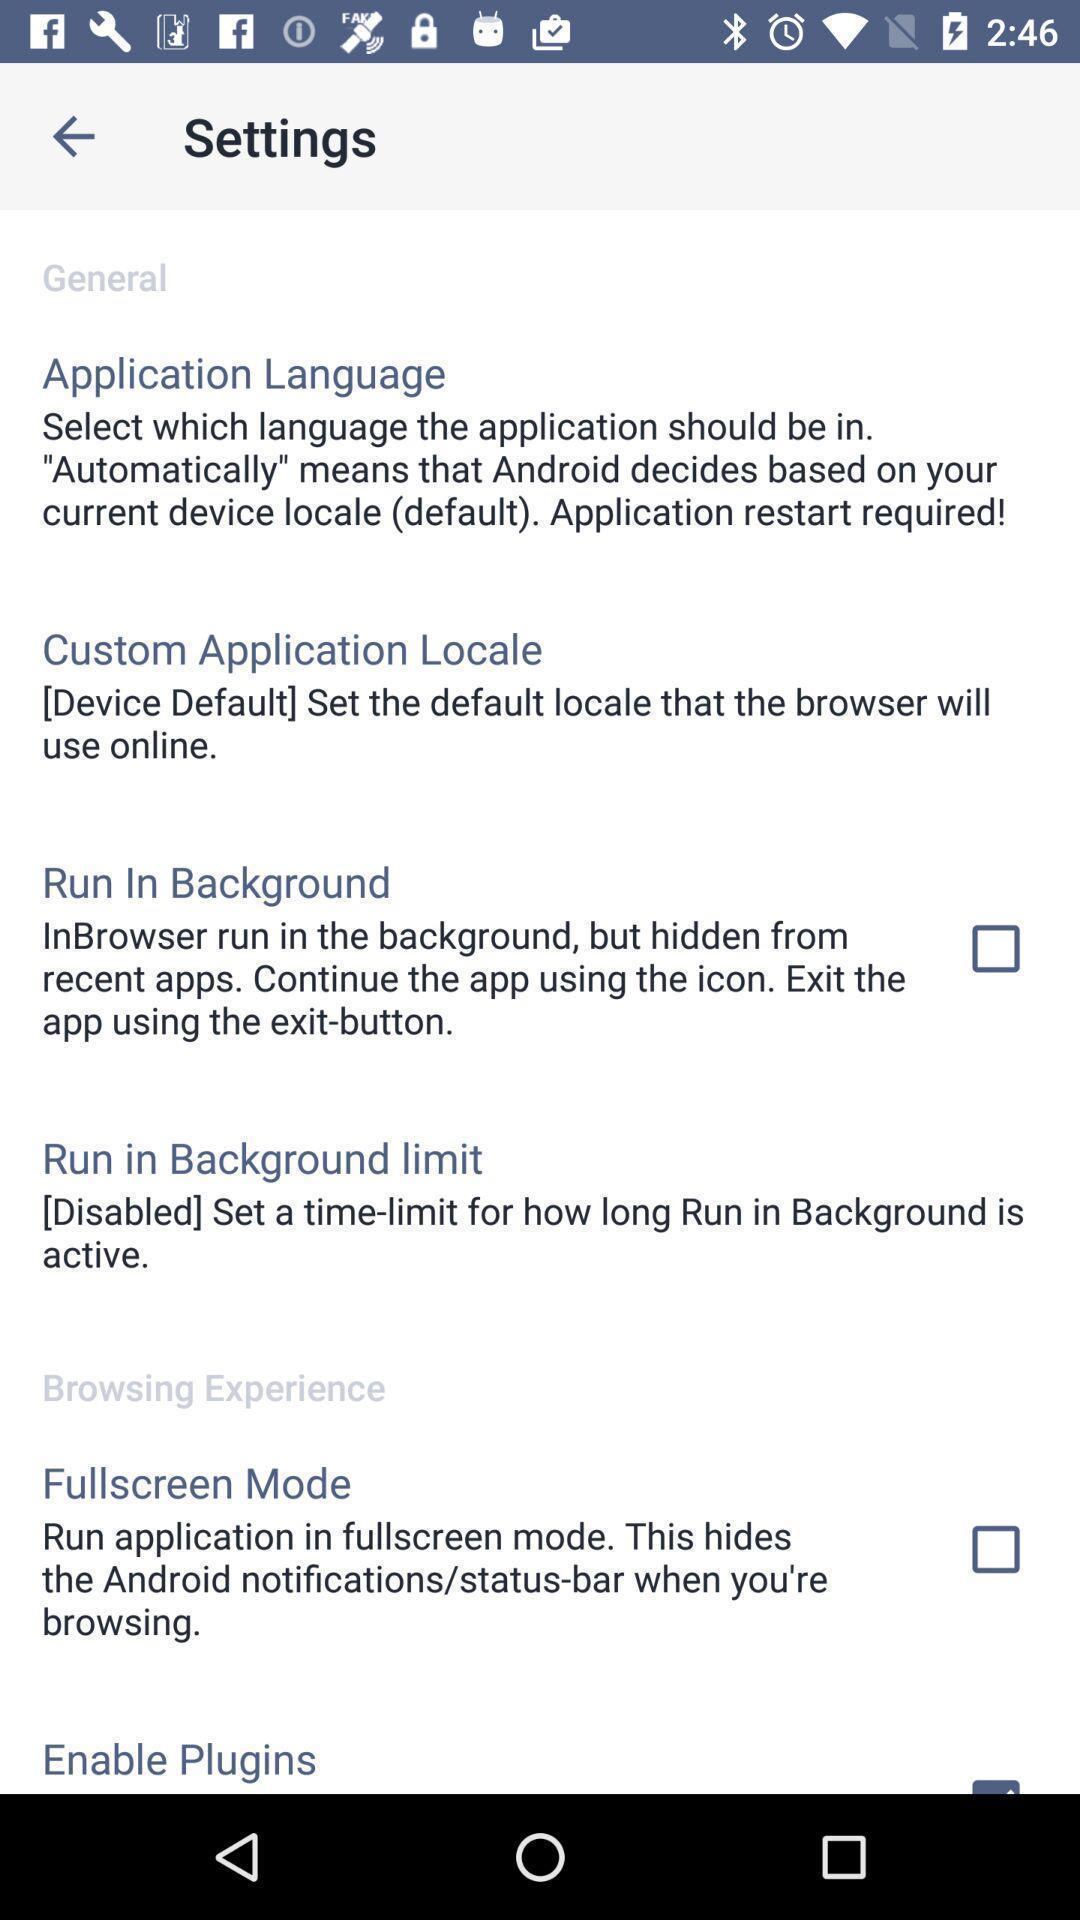Summarize the information in this screenshot. Settings page with various options. 